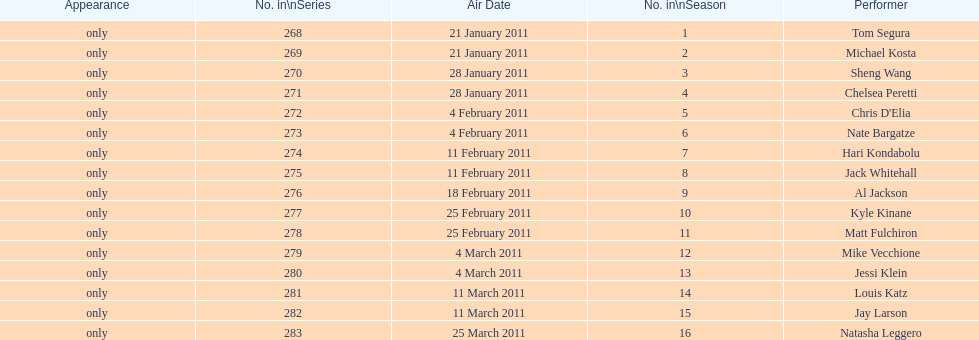How many performers appeared on the air date 21 january 2011? 2. 